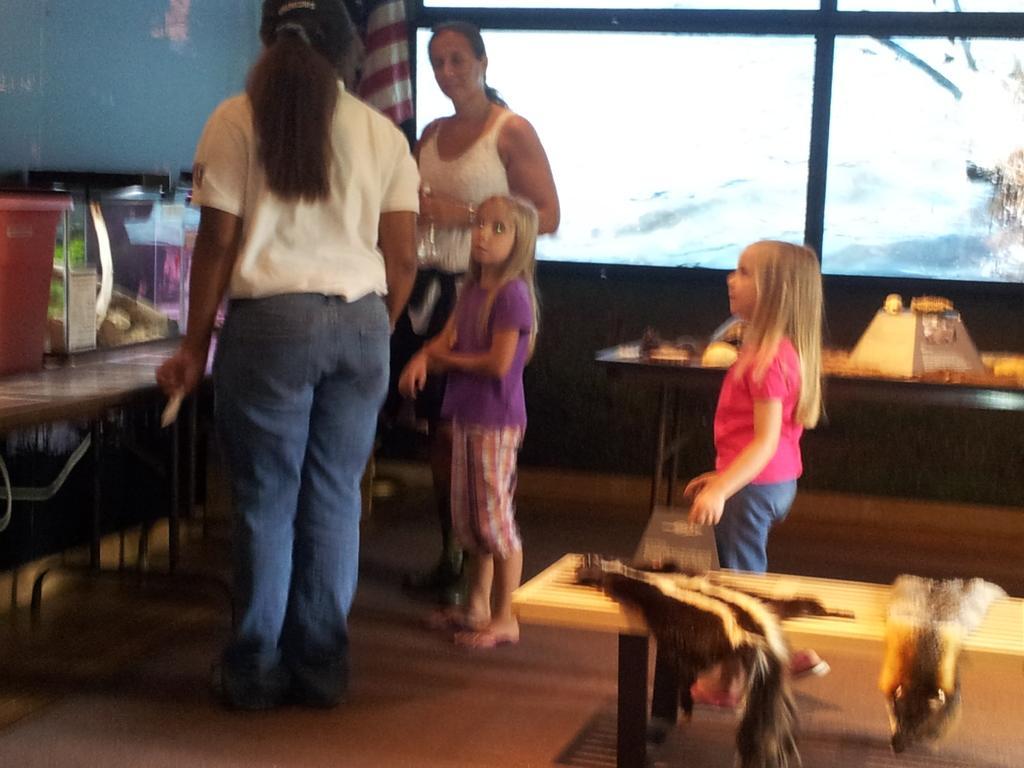Can you describe this image briefly? This image is taken inside a room. There are two kids and two women in this room. In the left side of the image there is a table on top that there is a bucket. In the right side of the image there is a bench and a animal skin on it, there is a glass window. At the bottom of the image there is a floor. At the background there is a wall and a flag. In the middle of the image a woman is standing. 